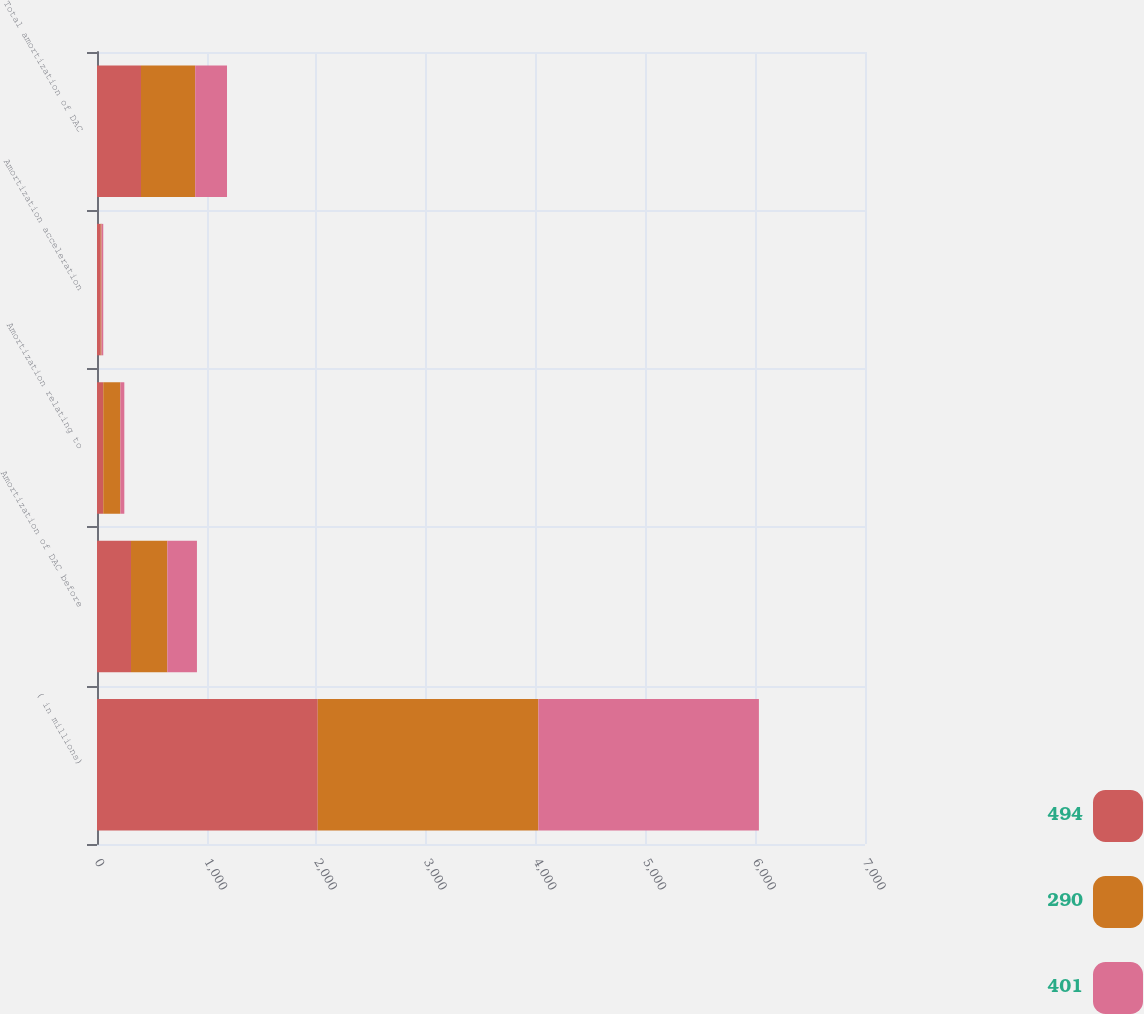Convert chart. <chart><loc_0><loc_0><loc_500><loc_500><stacked_bar_chart><ecel><fcel>( in millions)<fcel>Amortization of DAC before<fcel>Amortization relating to<fcel>Amortization acceleration<fcel>Total amortization of DAC<nl><fcel>494<fcel>2012<fcel>310<fcel>57<fcel>34<fcel>401<nl><fcel>290<fcel>2011<fcel>331<fcel>156<fcel>7<fcel>494<nl><fcel>401<fcel>2010<fcel>270<fcel>36<fcel>16<fcel>290<nl></chart> 